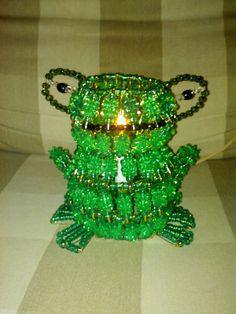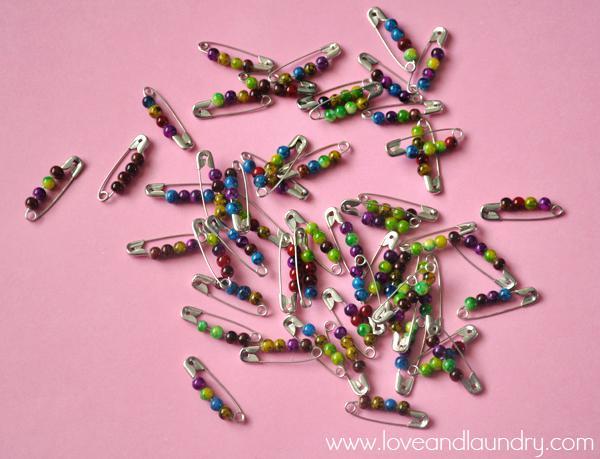The first image is the image on the left, the second image is the image on the right. Evaluate the accuracy of this statement regarding the images: "An image contains one pin jewelry with colored beads strung on silver safety pins to create a cartoon-like owl image.". Is it true? Answer yes or no. No. The first image is the image on the left, the second image is the image on the right. Considering the images on both sides, is "In one of the pictures, the beads are arranged to resemble an owl." valid? Answer yes or no. No. 